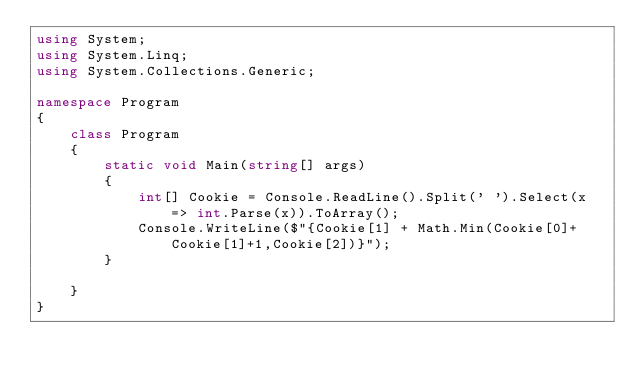Convert code to text. <code><loc_0><loc_0><loc_500><loc_500><_C#_>using System;
using System.Linq;
using System.Collections.Generic;

namespace Program
{
    class Program
    {
        static void Main(string[] args)
        {
            int[] Cookie = Console.ReadLine().Split(' ').Select(x => int.Parse(x)).ToArray();
            Console.WriteLine($"{Cookie[1] + Math.Min(Cookie[0]+Cookie[1]+1,Cookie[2])}");
        }

    }
}</code> 